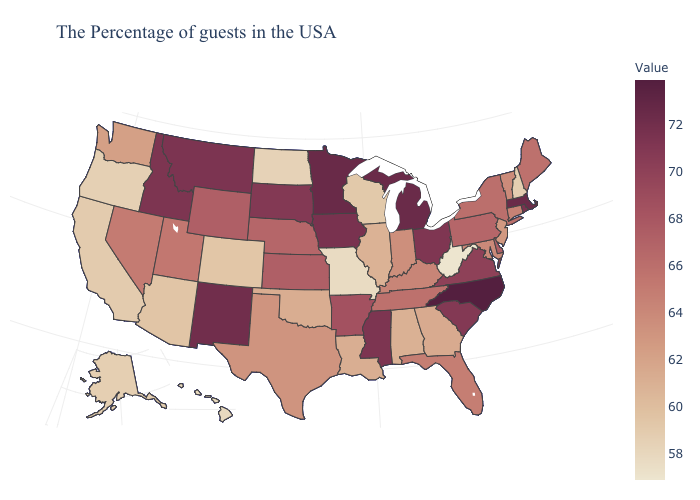Which states hav the highest value in the West?
Be succinct. New Mexico. Does Vermont have the highest value in the Northeast?
Give a very brief answer. No. Does Kentucky have the lowest value in the USA?
Quick response, please. No. Which states hav the highest value in the MidWest?
Answer briefly. Minnesota. Among the states that border Delaware , which have the highest value?
Short answer required. Pennsylvania. Which states have the lowest value in the USA?
Be succinct. West Virginia. Does Hawaii have the lowest value in the USA?
Quick response, please. No. Does Arizona have a higher value than Indiana?
Write a very short answer. No. Does Arkansas have a lower value than Mississippi?
Give a very brief answer. Yes. 